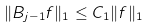<formula> <loc_0><loc_0><loc_500><loc_500>\| B _ { j - 1 } f \| _ { 1 } \leq C _ { 1 } \| f \| _ { 1 }</formula> 